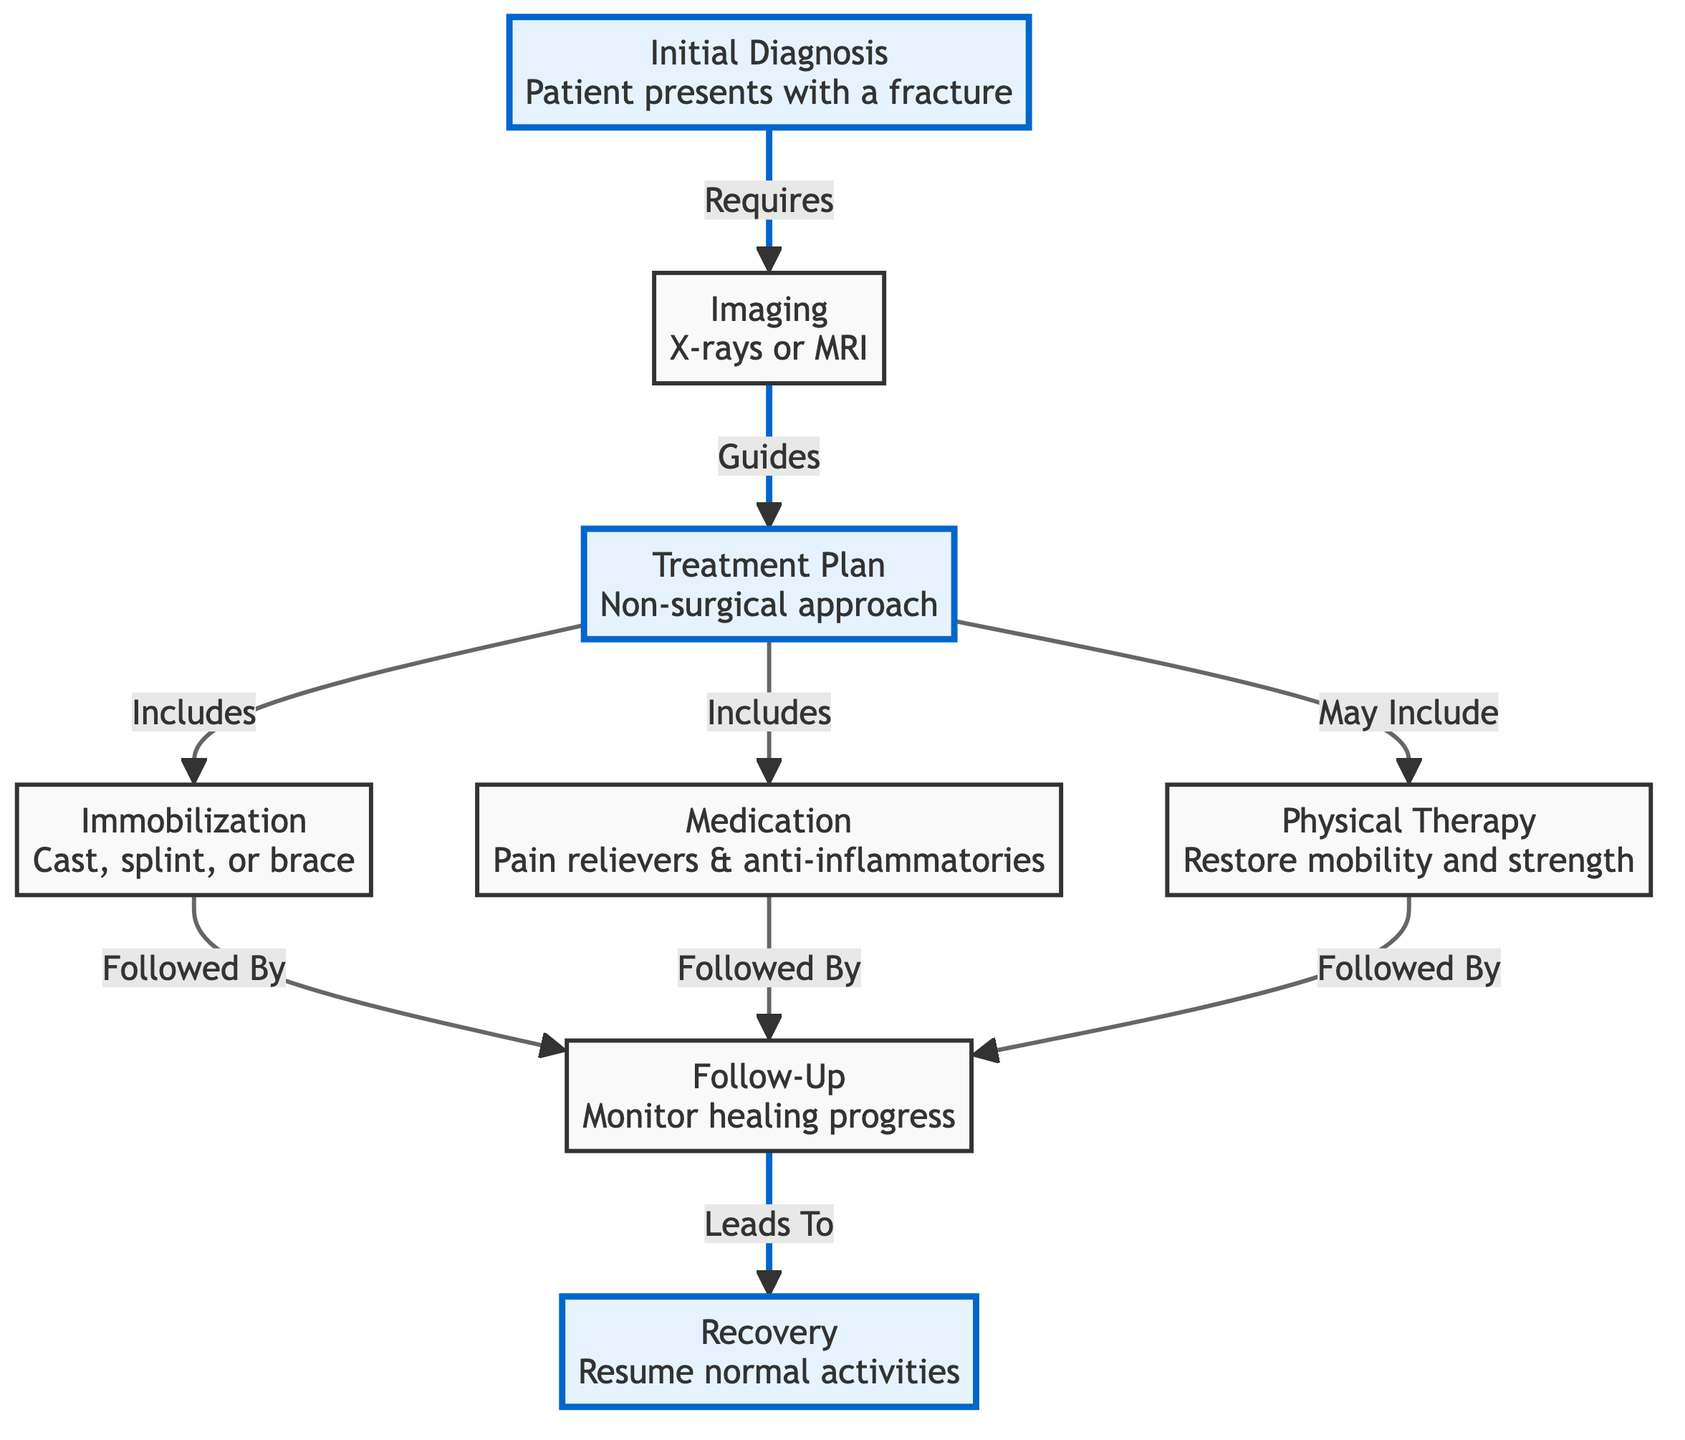What is the first step in the patient journey? The first step is the "Initial Diagnosis," where the patient presents with a fracture. This is the starting point of the flowchart.
Answer: Initial Diagnosis How many nodes are highlighted in the diagram? There are four highlighted nodes: "Initial Diagnosis," "Treatment Plan," "Recovery," and "Physical Therapy." Counting these highlighted nodes gives the total.
Answer: 4 What type of imaging is typically used for diagnosis? The diagram specifies "X-rays or MRI" as the types of imaging used after the initial diagnosis. This information is provided in the corresponding node.
Answer: X-rays or MRI Which treatment approach is mentioned in the diagram? The diagram mentions a "Non-surgical approach" as the treatment plan, indicating the type of treatment is non-invasive.
Answer: Non-surgical approach What follows the immobilization step? The "Follow-Up" step comes after immobilization. This indicates the patient's progress is monitored after the immobilization method is applied.
Answer: Follow-Up What is included in the treatment plan alongside medication? The diagram indicates that "Immobilization" is included in the treatment plan along with medication. This means both are essential components of the treatment.
Answer: Immobilization How many steps lead to recovery? There are four steps that lead to recovery: "Follow-Up" after immobilization, medication, and physical therapy. All these steps ultimately connect to recovery.
Answer: 4 What does physical therapy aim to restore? The purpose of "Physical Therapy," as stated in the node, is to "Restore mobility and strength," indicating its goal in the recovery process.
Answer: Restore mobility and strength What is the final outcome in the patient journey? The final outcome in the patient journey is "Resume normal activities," which represents the recovery phase after following all prior steps.
Answer: Resume normal activities 